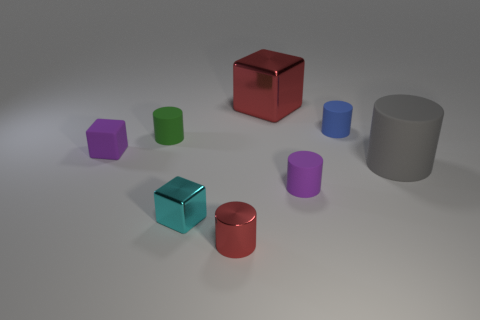Subtract all tiny purple cylinders. How many cylinders are left? 4 Subtract all green cylinders. How many cylinders are left? 4 Subtract all cyan cylinders. Subtract all red blocks. How many cylinders are left? 5 Add 2 large gray cylinders. How many objects exist? 10 Subtract all cylinders. How many objects are left? 3 Add 7 red shiny cylinders. How many red shiny cylinders exist? 8 Subtract 0 blue cubes. How many objects are left? 8 Subtract all big gray cylinders. Subtract all tiny green cylinders. How many objects are left? 6 Add 7 tiny purple cubes. How many tiny purple cubes are left? 8 